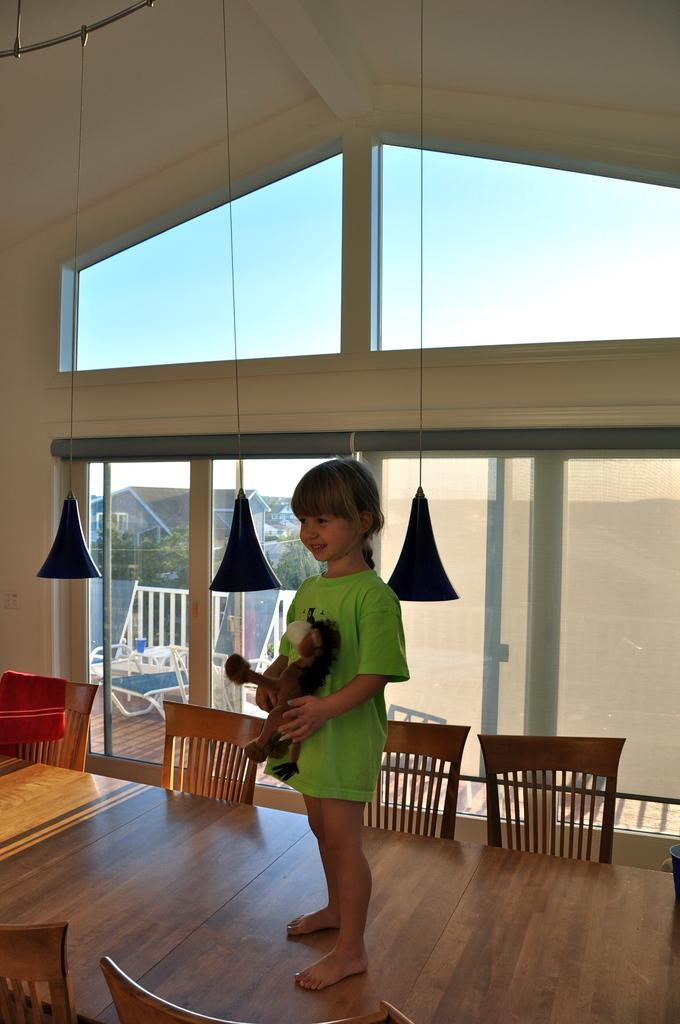What is the girl doing in the image? The girl is standing on the table in the image. What furniture is present around the table? There are chairs around the table in the image. What can be seen in the background of the image? There is a window and a wall in the background of the image. What is visible through the window? The sky is visible through the window in the image. What type of fang can be seen hanging from the girl's neck in the image? There is no fang present in the image; the girl is not wearing any necklace or accessory. What type of art is displayed on the wall in the image? There is no art displayed on the wall in the image; only a window and a wall are visible. 